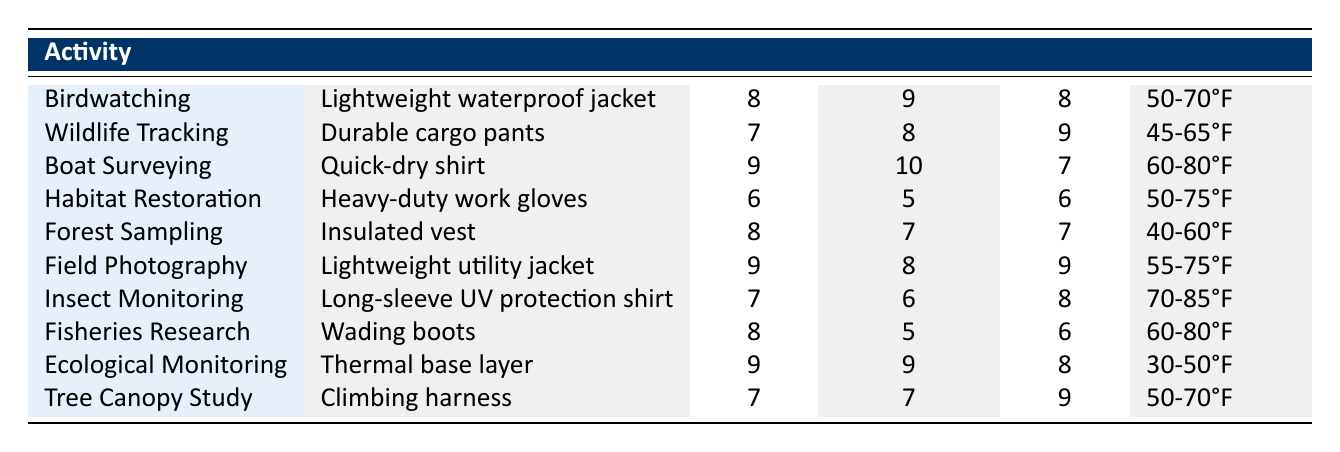What is the comfort rating for birdwatching? The table shows the comfort rating for birdwatching as 8.
Answer: 8 Which activity has the highest breathability rating? Boat surveying has the highest breathability rating of 10, as indicated in the table.
Answer: Boat Surveying What is the average comfort rating of all activities listed? The comfort ratings are 8, 7, 9, 6, 8, 9, 7, 8, 9, and 7. Summing these ratings gives 78. There are 10 activities, so the average is 78 / 10 = 7.8.
Answer: 7.8 Is the comfort rating for wildlife tracking greater than 7? Wildlife tracking has a comfort rating of 7. Since 7 is not greater than 7, the answer is no.
Answer: No What is the temperature range for habitat restoration? According to the table, the temperature range for habitat restoration is 50-75°F.
Answer: 50-75°F How many activities have a comfort rating of 9 or higher? The activities with a comfort rating of 9 or higher are birdwatching, boat surveying, field photography, and ecological monitoring. That makes a total of 4 activities.
Answer: 4 Which outer layer type has the lowest mobility rating, and what is that rating? The table shows that heavy-duty work gloves have the lowest mobility rating of 6 when reviewed across all activities.
Answer: Heavy-duty work gloves, 6 For how many activities is the temperature range below 60°F? The activities with a temperature range below 60°F are forest sampling (40-60°F) and ecological monitoring (30-50°F), totaling 2 activities.
Answer: 2 Does insect monitoring have a mobility rating of more than 7? Insect monitoring has a mobility rating of 8, which is greater than 7. Therefore, the answer is yes.
Answer: Yes 